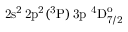<formula> <loc_0><loc_0><loc_500><loc_500>2 s ^ { 2 } \, 2 p ^ { 2 } ( ^ { 3 } P ) \, 3 p ^ { 4 } D _ { 7 / 2 } ^ { o }</formula> 